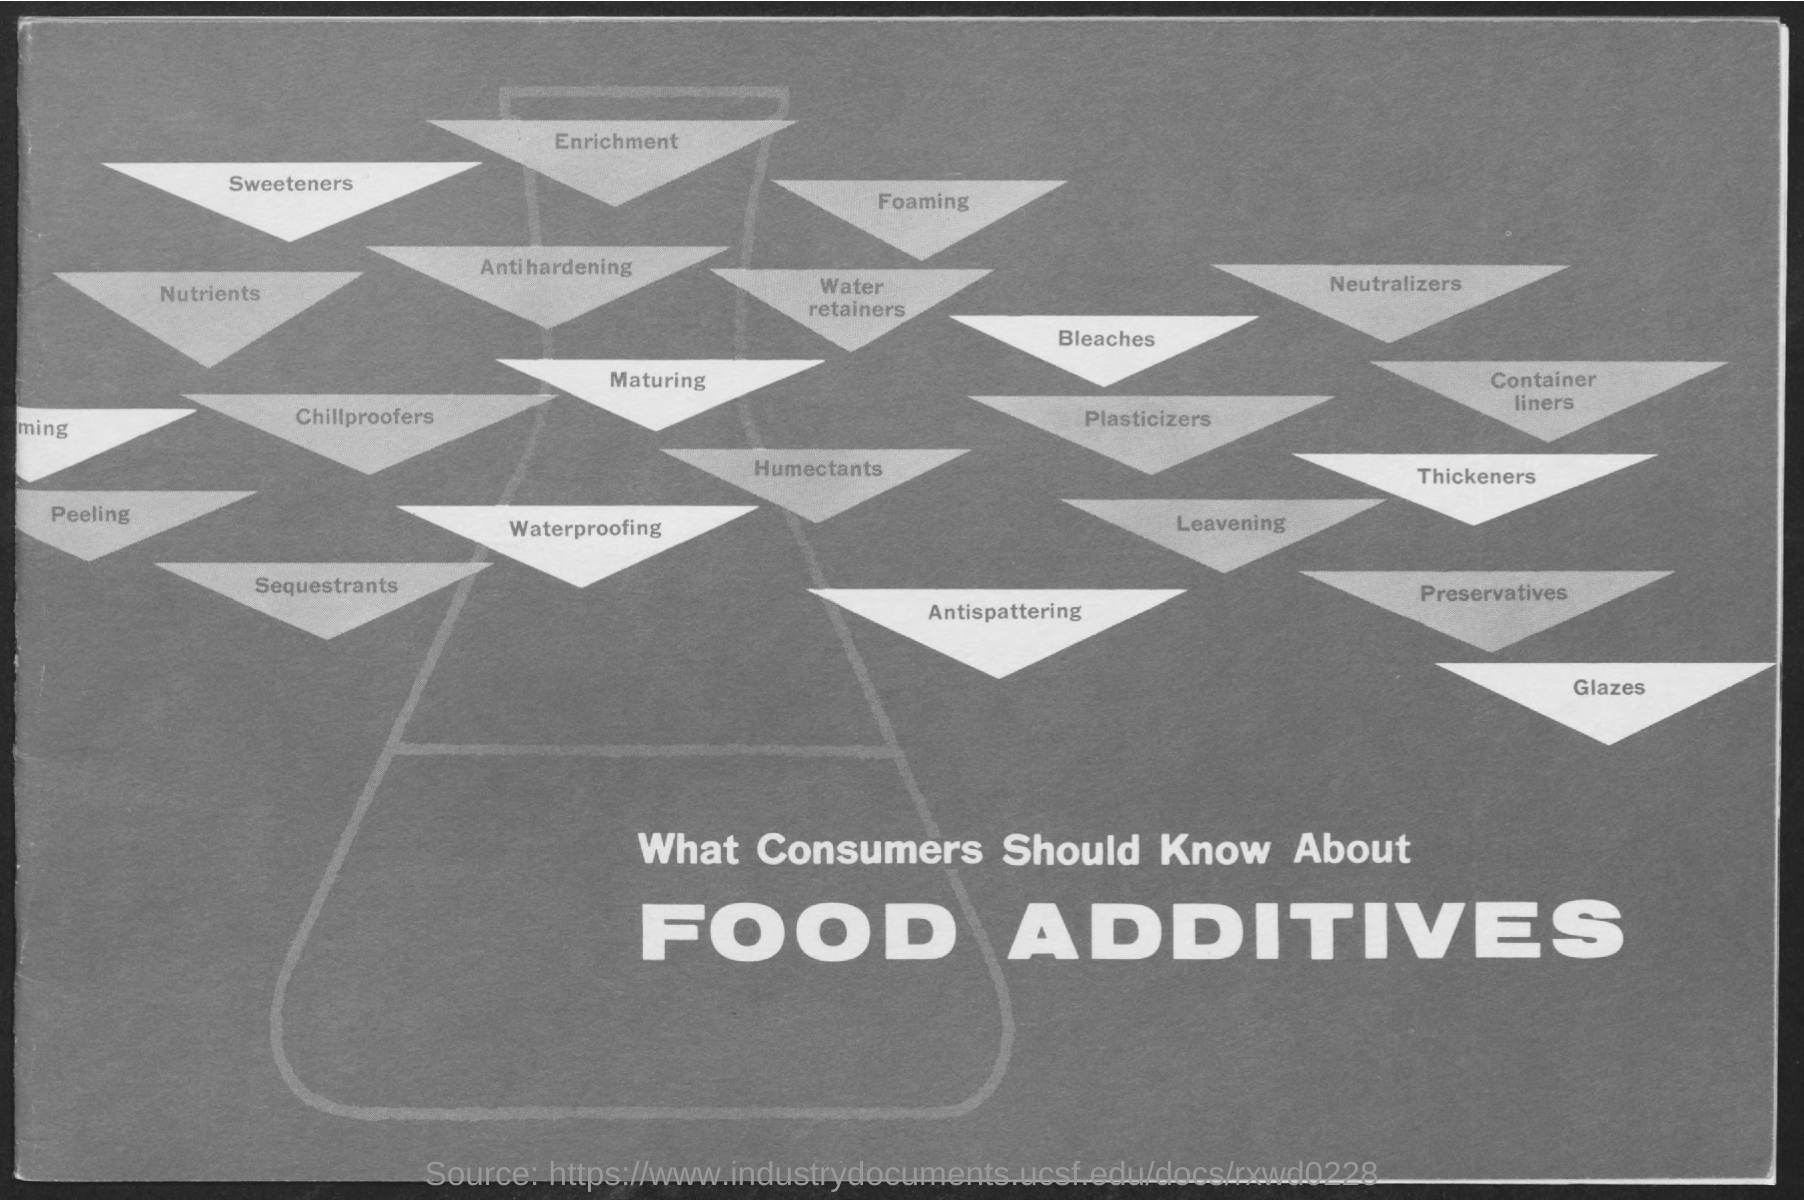Indicate a few pertinent items in this graphic. The title is 'What Consumers Should Know about Food Additives.' 